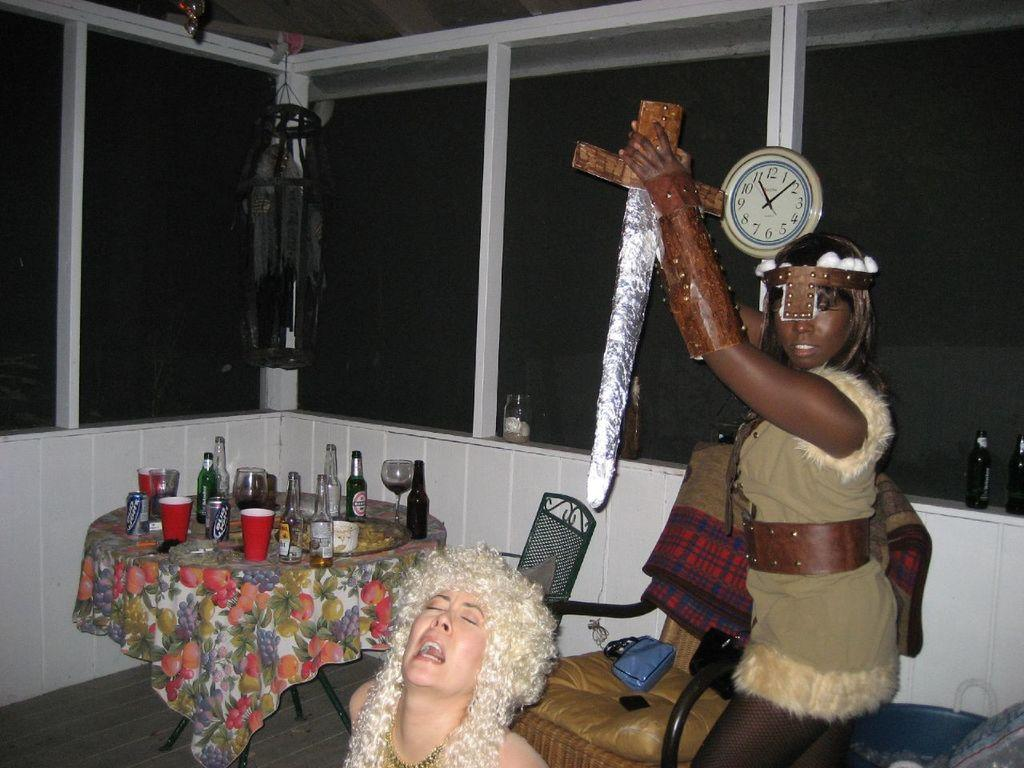Provide a one-sentence caption for the provided image. Women in costumes next to a table with empty cans of Bud Light on it. 